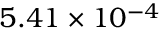Convert formula to latex. <formula><loc_0><loc_0><loc_500><loc_500>5 . 4 1 \times { 1 0 ^ { - 4 } }</formula> 